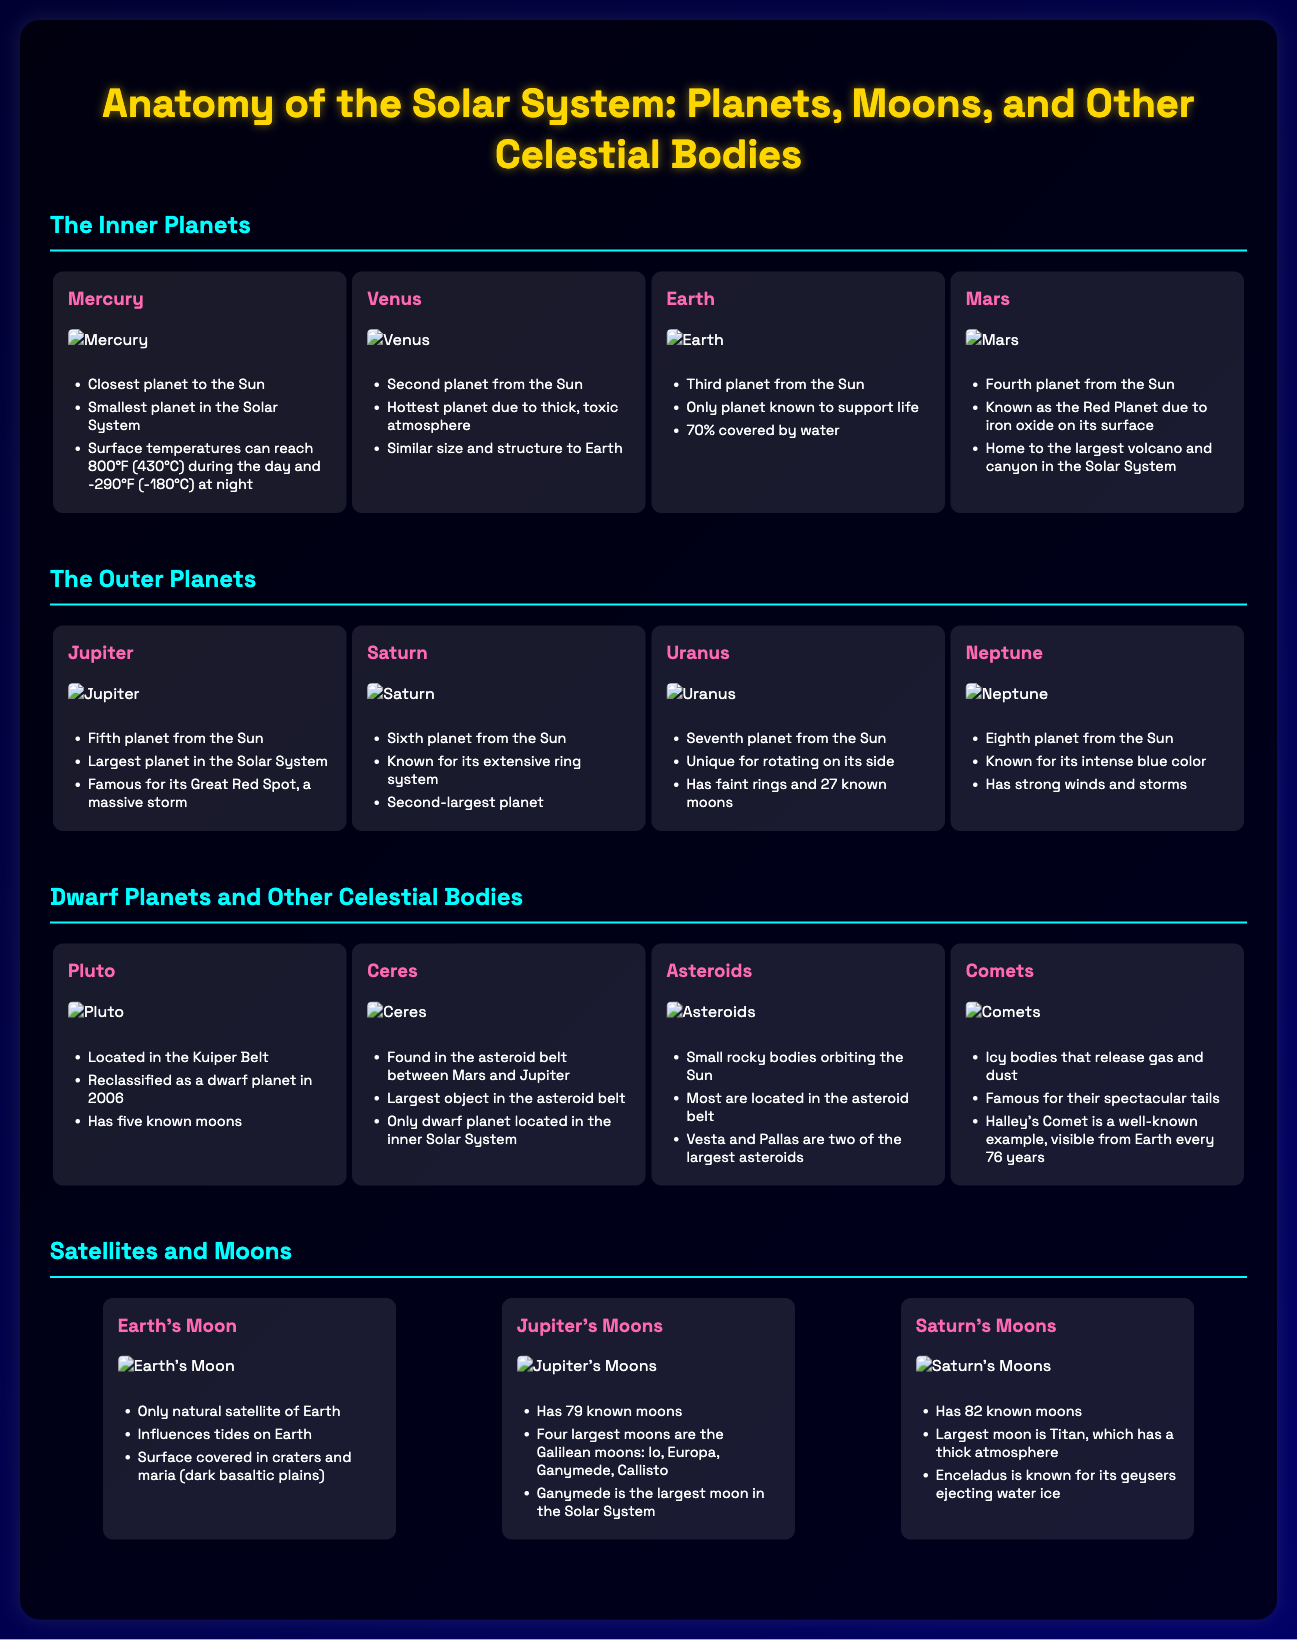What is the second planet from the Sun? The second planet from the Sun is Venus, as listed in the document.
Answer: Venus How many known moons does Jupiter have? Jupiter has 79 known moons, according to the document.
Answer: 79 What is the temperature range of Mercury? The temperature range of Mercury can reach 800°F (430°C) during the day and -290°F (-180°C) at night, as stated in the document.
Answer: 800°F (430°C) and -290°F (-180°C) Which planet is known for its extensive ring system? Saturn is known for its extensive ring system, as highlighted in the document.
Answer: Saturn What is the largest moon in the Solar System? The largest moon in the Solar System is Ganymede, mentioned in the Jupiter's moons section.
Answer: Ganymede What is Halley's Comet famous for? Halley's Comet is famous for being visible from Earth every 76 years, as noted in the document.
Answer: Visible from Earth every 76 years Which dwarf planet is located in the Kuiper Belt? Pluto is located in the Kuiper Belt, according to the information provided in the document.
Answer: Pluto What is Earth's Moon's influence on Earth? Earth's Moon influences tides on Earth, as stated in the document.
Answer: Influences tides How many known moons does Saturn have? Saturn has 82 known moons, as listed in the document.
Answer: 82 